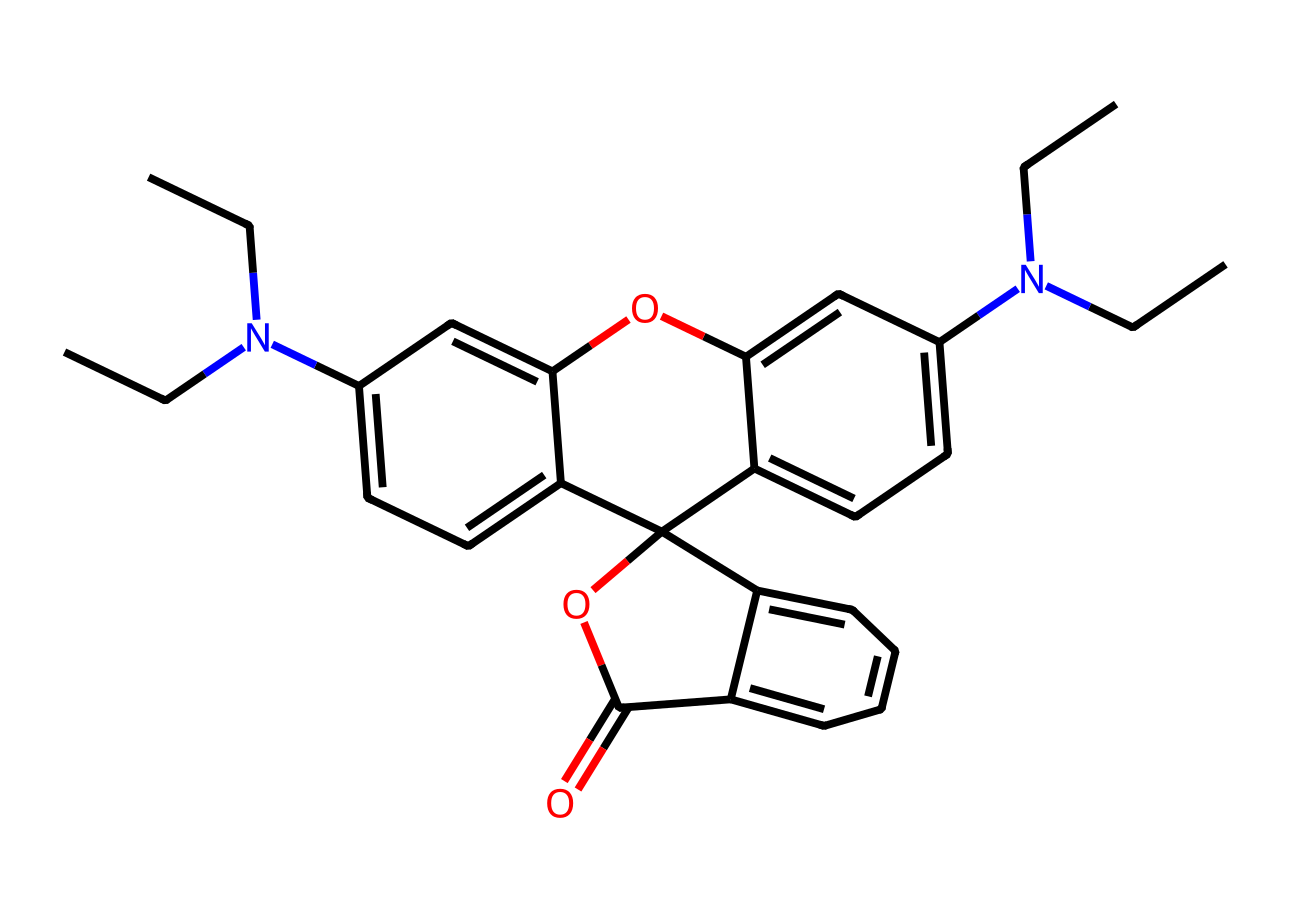What is the primary color of rhodamine B? The structure suggests the presence of conjugated double bonds and aromatic systems, which usually produce bright colors. Specifically, rhodamine B is known for its vibrant pink color.
Answer: pink How many nitrogen atoms are present in rhodamine B? By examining the SMILES representation, we can count the nitrogen atoms, which are indicated by 'N'. There are two nitrogen atoms in the structure of rhodamine B.
Answer: 2 What functional group is indicated by the 'OC(=O)' in the chemical structure? The 'OC(=O)' portion denotes a carboxylate or ester functional group, which typically have properties that affect solubility and reactivity in dyes.
Answer: ester How many rings are present in the rhodamine B structure? Looking at the way the carbon atoms are organized in the structure, followed by analyzing connected cycles, we can see there are two fused aromatic rings in rhodamine B.
Answer: 2 What atomic element is responsible for the dye's fluorescent properties? The conjugated system present and the unique arrangement of the nitrogen and carbon atoms lead to electron excitation, primarily involving the nitrogen atoms, which are key in absorbance and fluorescence.
Answer: nitrogen What category of dyes does rhodamine B belong to? Rhodamine B is characterized as a synthetic organic dye, with an emphasis on being a fluorescent dye, which is commonly used in fabric coloration.
Answer: synthetic organic dye 